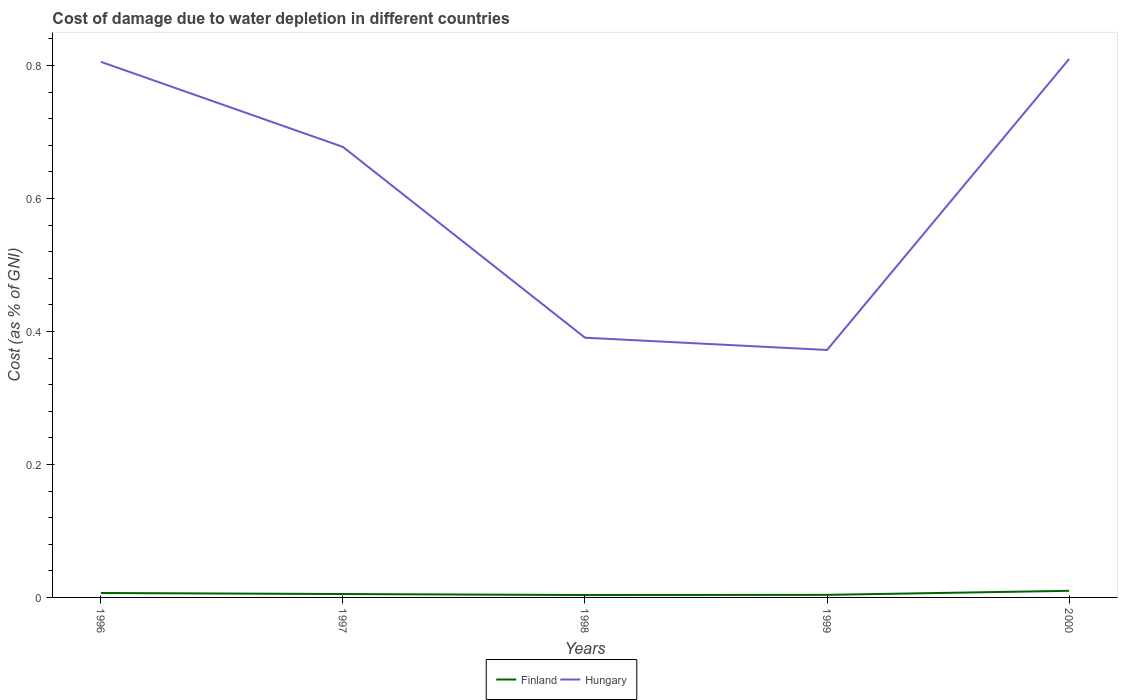Across all years, what is the maximum cost of damage caused due to water depletion in Finland?
Provide a short and direct response. 0. In which year was the cost of damage caused due to water depletion in Hungary maximum?
Offer a very short reply. 1999. What is the total cost of damage caused due to water depletion in Hungary in the graph?
Give a very brief answer. 0.31. What is the difference between the highest and the second highest cost of damage caused due to water depletion in Hungary?
Offer a terse response. 0.44. Is the cost of damage caused due to water depletion in Hungary strictly greater than the cost of damage caused due to water depletion in Finland over the years?
Your response must be concise. No. Does the graph contain any zero values?
Your answer should be very brief. No. Does the graph contain grids?
Your answer should be very brief. No. Where does the legend appear in the graph?
Provide a short and direct response. Bottom center. How are the legend labels stacked?
Ensure brevity in your answer.  Horizontal. What is the title of the graph?
Provide a short and direct response. Cost of damage due to water depletion in different countries. Does "Tonga" appear as one of the legend labels in the graph?
Provide a succinct answer. No. What is the label or title of the Y-axis?
Make the answer very short. Cost (as % of GNI). What is the Cost (as % of GNI) of Finland in 1996?
Ensure brevity in your answer.  0.01. What is the Cost (as % of GNI) of Hungary in 1996?
Offer a terse response. 0.81. What is the Cost (as % of GNI) of Finland in 1997?
Make the answer very short. 0.01. What is the Cost (as % of GNI) in Hungary in 1997?
Provide a short and direct response. 0.68. What is the Cost (as % of GNI) of Finland in 1998?
Ensure brevity in your answer.  0. What is the Cost (as % of GNI) in Hungary in 1998?
Your response must be concise. 0.39. What is the Cost (as % of GNI) in Finland in 1999?
Your answer should be compact. 0. What is the Cost (as % of GNI) in Hungary in 1999?
Give a very brief answer. 0.37. What is the Cost (as % of GNI) in Finland in 2000?
Offer a very short reply. 0.01. What is the Cost (as % of GNI) of Hungary in 2000?
Your answer should be very brief. 0.81. Across all years, what is the maximum Cost (as % of GNI) of Finland?
Give a very brief answer. 0.01. Across all years, what is the maximum Cost (as % of GNI) of Hungary?
Provide a succinct answer. 0.81. Across all years, what is the minimum Cost (as % of GNI) of Finland?
Keep it short and to the point. 0. Across all years, what is the minimum Cost (as % of GNI) in Hungary?
Your answer should be compact. 0.37. What is the total Cost (as % of GNI) in Finland in the graph?
Ensure brevity in your answer.  0.03. What is the total Cost (as % of GNI) in Hungary in the graph?
Ensure brevity in your answer.  3.06. What is the difference between the Cost (as % of GNI) of Finland in 1996 and that in 1997?
Make the answer very short. 0. What is the difference between the Cost (as % of GNI) in Hungary in 1996 and that in 1997?
Keep it short and to the point. 0.13. What is the difference between the Cost (as % of GNI) in Finland in 1996 and that in 1998?
Provide a succinct answer. 0. What is the difference between the Cost (as % of GNI) of Hungary in 1996 and that in 1998?
Provide a succinct answer. 0.41. What is the difference between the Cost (as % of GNI) in Finland in 1996 and that in 1999?
Your answer should be compact. 0. What is the difference between the Cost (as % of GNI) in Hungary in 1996 and that in 1999?
Provide a succinct answer. 0.43. What is the difference between the Cost (as % of GNI) in Finland in 1996 and that in 2000?
Ensure brevity in your answer.  -0. What is the difference between the Cost (as % of GNI) in Hungary in 1996 and that in 2000?
Offer a terse response. -0. What is the difference between the Cost (as % of GNI) of Finland in 1997 and that in 1998?
Your response must be concise. 0. What is the difference between the Cost (as % of GNI) of Hungary in 1997 and that in 1998?
Your answer should be compact. 0.29. What is the difference between the Cost (as % of GNI) in Finland in 1997 and that in 1999?
Provide a short and direct response. 0. What is the difference between the Cost (as % of GNI) of Hungary in 1997 and that in 1999?
Provide a short and direct response. 0.31. What is the difference between the Cost (as % of GNI) in Finland in 1997 and that in 2000?
Give a very brief answer. -0. What is the difference between the Cost (as % of GNI) in Hungary in 1997 and that in 2000?
Ensure brevity in your answer.  -0.13. What is the difference between the Cost (as % of GNI) in Finland in 1998 and that in 1999?
Offer a terse response. -0. What is the difference between the Cost (as % of GNI) in Hungary in 1998 and that in 1999?
Make the answer very short. 0.02. What is the difference between the Cost (as % of GNI) of Finland in 1998 and that in 2000?
Provide a short and direct response. -0.01. What is the difference between the Cost (as % of GNI) of Hungary in 1998 and that in 2000?
Make the answer very short. -0.42. What is the difference between the Cost (as % of GNI) of Finland in 1999 and that in 2000?
Offer a terse response. -0.01. What is the difference between the Cost (as % of GNI) in Hungary in 1999 and that in 2000?
Your response must be concise. -0.44. What is the difference between the Cost (as % of GNI) in Finland in 1996 and the Cost (as % of GNI) in Hungary in 1997?
Give a very brief answer. -0.67. What is the difference between the Cost (as % of GNI) of Finland in 1996 and the Cost (as % of GNI) of Hungary in 1998?
Offer a terse response. -0.38. What is the difference between the Cost (as % of GNI) of Finland in 1996 and the Cost (as % of GNI) of Hungary in 1999?
Give a very brief answer. -0.37. What is the difference between the Cost (as % of GNI) in Finland in 1996 and the Cost (as % of GNI) in Hungary in 2000?
Offer a terse response. -0.8. What is the difference between the Cost (as % of GNI) of Finland in 1997 and the Cost (as % of GNI) of Hungary in 1998?
Give a very brief answer. -0.39. What is the difference between the Cost (as % of GNI) of Finland in 1997 and the Cost (as % of GNI) of Hungary in 1999?
Provide a short and direct response. -0.37. What is the difference between the Cost (as % of GNI) of Finland in 1997 and the Cost (as % of GNI) of Hungary in 2000?
Ensure brevity in your answer.  -0.8. What is the difference between the Cost (as % of GNI) of Finland in 1998 and the Cost (as % of GNI) of Hungary in 1999?
Ensure brevity in your answer.  -0.37. What is the difference between the Cost (as % of GNI) of Finland in 1998 and the Cost (as % of GNI) of Hungary in 2000?
Give a very brief answer. -0.81. What is the difference between the Cost (as % of GNI) in Finland in 1999 and the Cost (as % of GNI) in Hungary in 2000?
Give a very brief answer. -0.81. What is the average Cost (as % of GNI) of Finland per year?
Your answer should be compact. 0.01. What is the average Cost (as % of GNI) of Hungary per year?
Offer a very short reply. 0.61. In the year 1996, what is the difference between the Cost (as % of GNI) in Finland and Cost (as % of GNI) in Hungary?
Provide a succinct answer. -0.8. In the year 1997, what is the difference between the Cost (as % of GNI) of Finland and Cost (as % of GNI) of Hungary?
Keep it short and to the point. -0.67. In the year 1998, what is the difference between the Cost (as % of GNI) of Finland and Cost (as % of GNI) of Hungary?
Your answer should be compact. -0.39. In the year 1999, what is the difference between the Cost (as % of GNI) in Finland and Cost (as % of GNI) in Hungary?
Provide a succinct answer. -0.37. In the year 2000, what is the difference between the Cost (as % of GNI) in Finland and Cost (as % of GNI) in Hungary?
Provide a short and direct response. -0.8. What is the ratio of the Cost (as % of GNI) in Finland in 1996 to that in 1997?
Keep it short and to the point. 1.3. What is the ratio of the Cost (as % of GNI) in Hungary in 1996 to that in 1997?
Provide a succinct answer. 1.19. What is the ratio of the Cost (as % of GNI) of Finland in 1996 to that in 1998?
Make the answer very short. 1.86. What is the ratio of the Cost (as % of GNI) in Hungary in 1996 to that in 1998?
Your answer should be very brief. 2.06. What is the ratio of the Cost (as % of GNI) in Finland in 1996 to that in 1999?
Your answer should be very brief. 1.72. What is the ratio of the Cost (as % of GNI) of Hungary in 1996 to that in 1999?
Offer a very short reply. 2.16. What is the ratio of the Cost (as % of GNI) in Finland in 1996 to that in 2000?
Provide a short and direct response. 0.67. What is the ratio of the Cost (as % of GNI) in Hungary in 1996 to that in 2000?
Your response must be concise. 0.99. What is the ratio of the Cost (as % of GNI) of Finland in 1997 to that in 1998?
Offer a terse response. 1.42. What is the ratio of the Cost (as % of GNI) of Hungary in 1997 to that in 1998?
Your answer should be compact. 1.73. What is the ratio of the Cost (as % of GNI) in Finland in 1997 to that in 1999?
Your response must be concise. 1.32. What is the ratio of the Cost (as % of GNI) of Hungary in 1997 to that in 1999?
Provide a succinct answer. 1.82. What is the ratio of the Cost (as % of GNI) in Finland in 1997 to that in 2000?
Your answer should be very brief. 0.51. What is the ratio of the Cost (as % of GNI) in Hungary in 1997 to that in 2000?
Your answer should be compact. 0.84. What is the ratio of the Cost (as % of GNI) of Finland in 1998 to that in 1999?
Keep it short and to the point. 0.93. What is the ratio of the Cost (as % of GNI) in Hungary in 1998 to that in 1999?
Your answer should be very brief. 1.05. What is the ratio of the Cost (as % of GNI) of Finland in 1998 to that in 2000?
Your response must be concise. 0.36. What is the ratio of the Cost (as % of GNI) in Hungary in 1998 to that in 2000?
Offer a terse response. 0.48. What is the ratio of the Cost (as % of GNI) of Finland in 1999 to that in 2000?
Make the answer very short. 0.39. What is the ratio of the Cost (as % of GNI) of Hungary in 1999 to that in 2000?
Your answer should be very brief. 0.46. What is the difference between the highest and the second highest Cost (as % of GNI) in Finland?
Your answer should be very brief. 0. What is the difference between the highest and the second highest Cost (as % of GNI) in Hungary?
Your answer should be very brief. 0. What is the difference between the highest and the lowest Cost (as % of GNI) in Finland?
Provide a short and direct response. 0.01. What is the difference between the highest and the lowest Cost (as % of GNI) in Hungary?
Your response must be concise. 0.44. 